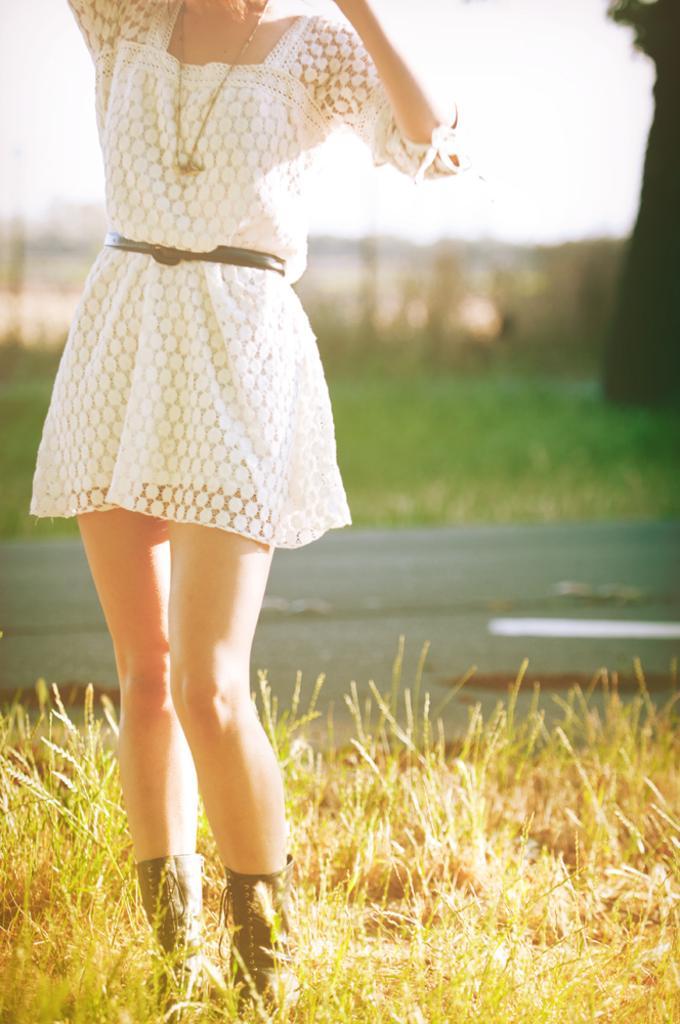Please provide a concise description of this image. In this image, we can see a girl who is wearing a white dress and she is also wearing a chain in her neck and she is wearing boots and standing in the grass and there is also a road, behind the road there is grass which is green in color 